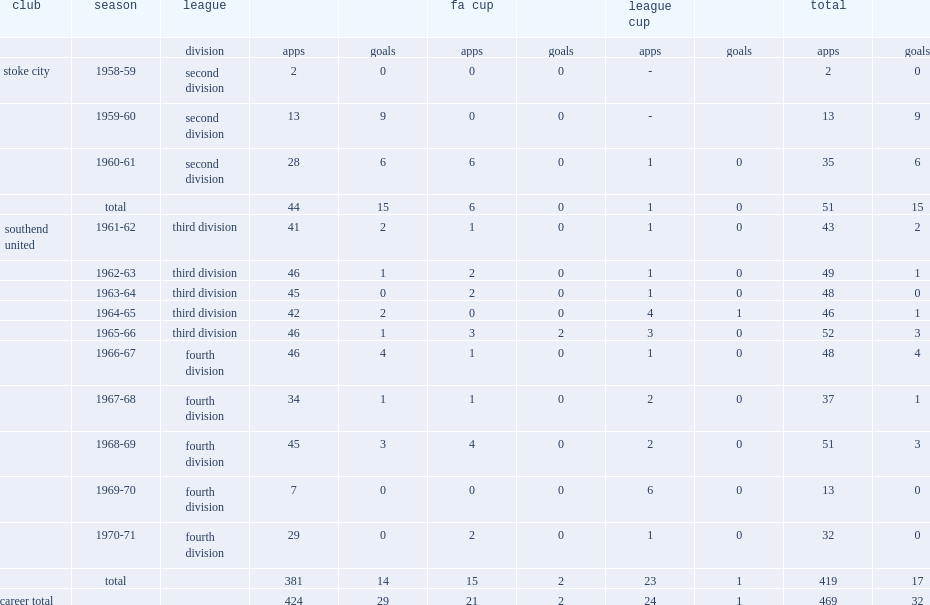In the 1960s bentley played ten seasons, how many appearances did the southend united club rack up? 419.0. 